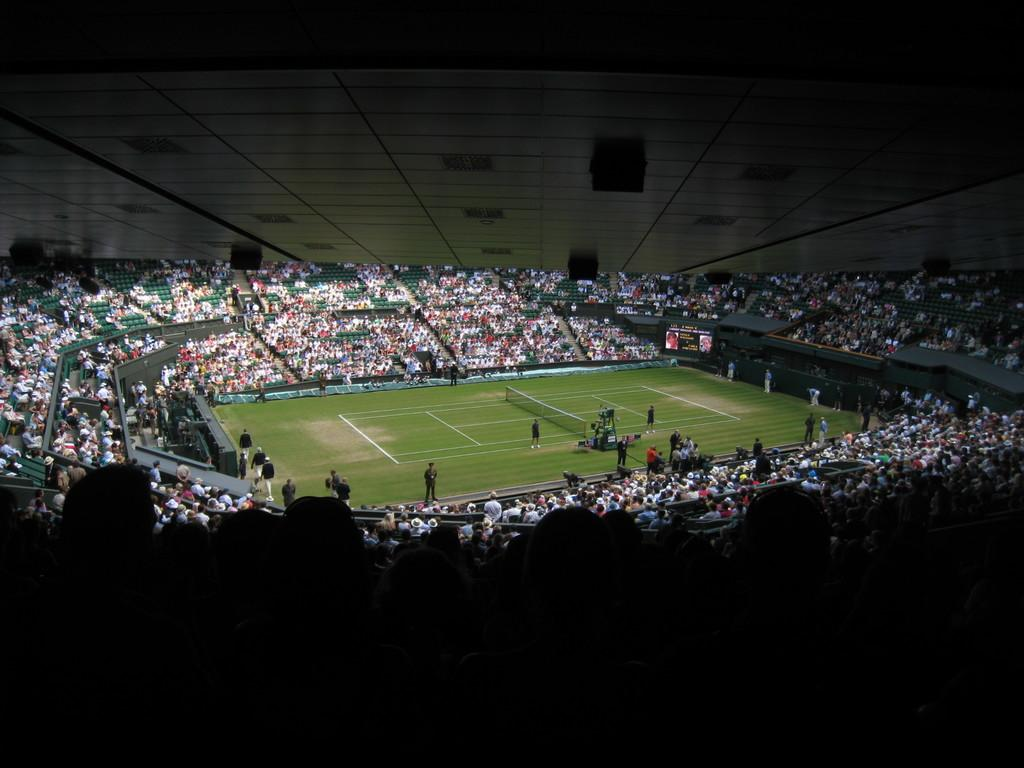How many people can be seen in the image? There are many people in the image, from left to right. What is the position of some people in the image? There are a few people on the ground. What is placed on the ground in the image? There is a net on the ground. What is visible in the image besides the people and the net? There is a board visible in the image. What can be seen on top of the board or another surface in the image? There are some black objects on top of the board or another surface. What is the value of the skin of the people in the image? There is no mention of the value of the skin of the people in the image, as the focus is on their position and the objects around them. 